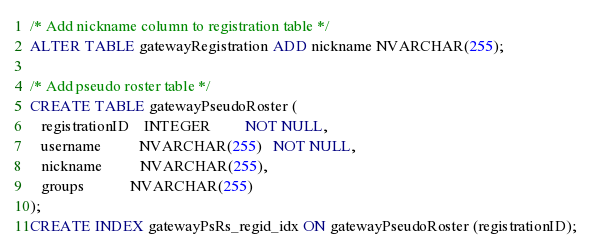<code> <loc_0><loc_0><loc_500><loc_500><_SQL_>/* Add nickname column to registration table */
ALTER TABLE gatewayRegistration ADD nickname NVARCHAR(255);

/* Add pseudo roster table */
CREATE TABLE gatewayPseudoRoster (
   registrationID    INTEGER         NOT NULL,
   username          NVARCHAR(255)   NOT NULL,
   nickname          NVARCHAR(255),
   groups            NVARCHAR(255)
);
CREATE INDEX gatewayPsRs_regid_idx ON gatewayPseudoRoster (registrationID);</code> 